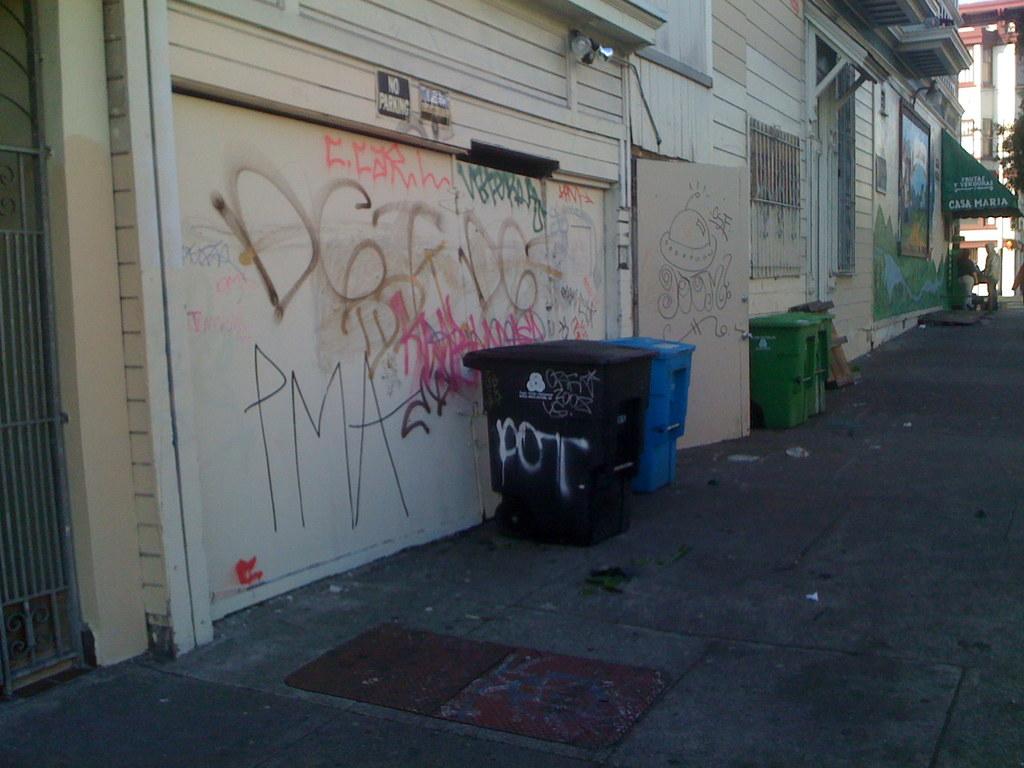What does some of this graffiti say?
Offer a terse response. Pma. What is written on the trash can?
Your answer should be compact. Pot. 